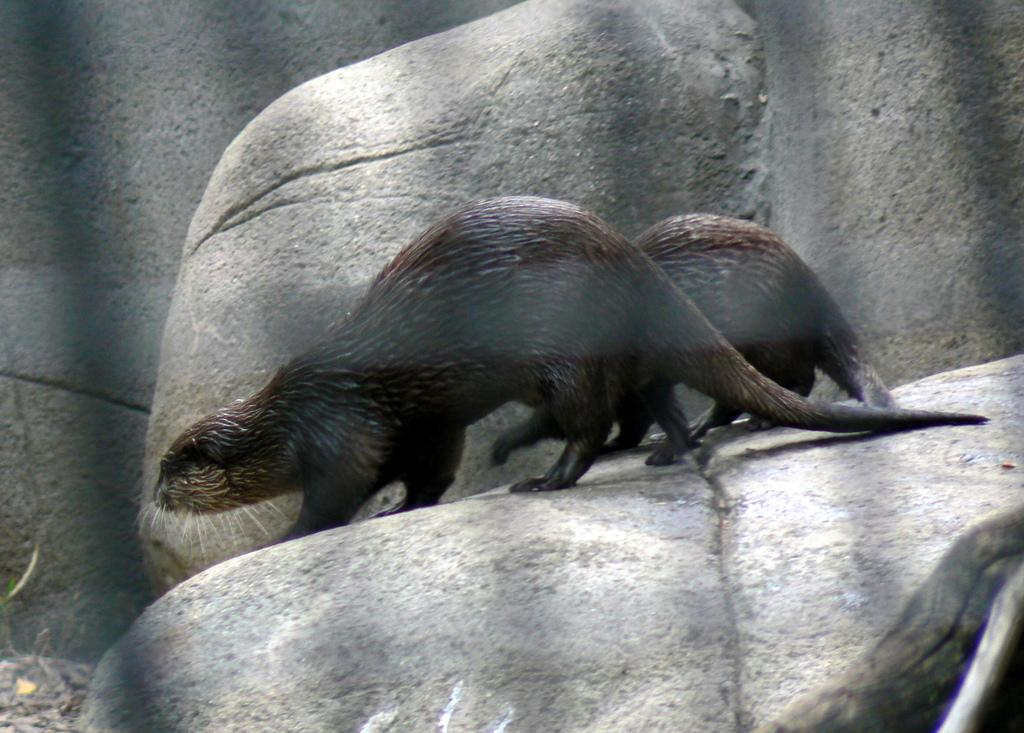How many animals can be seen in the image? There are two animals in the image. What are the animals doing in the image? The animals are standing on a rock. Where is the rock located in the image? The rock is in the middle of the image. What can be seen in the background of the image? There are rocks in the background of the image. What type of hole can be seen in the image? There is no hole present in the image. What recess is visible in the image? There is no recess visible in the image. 